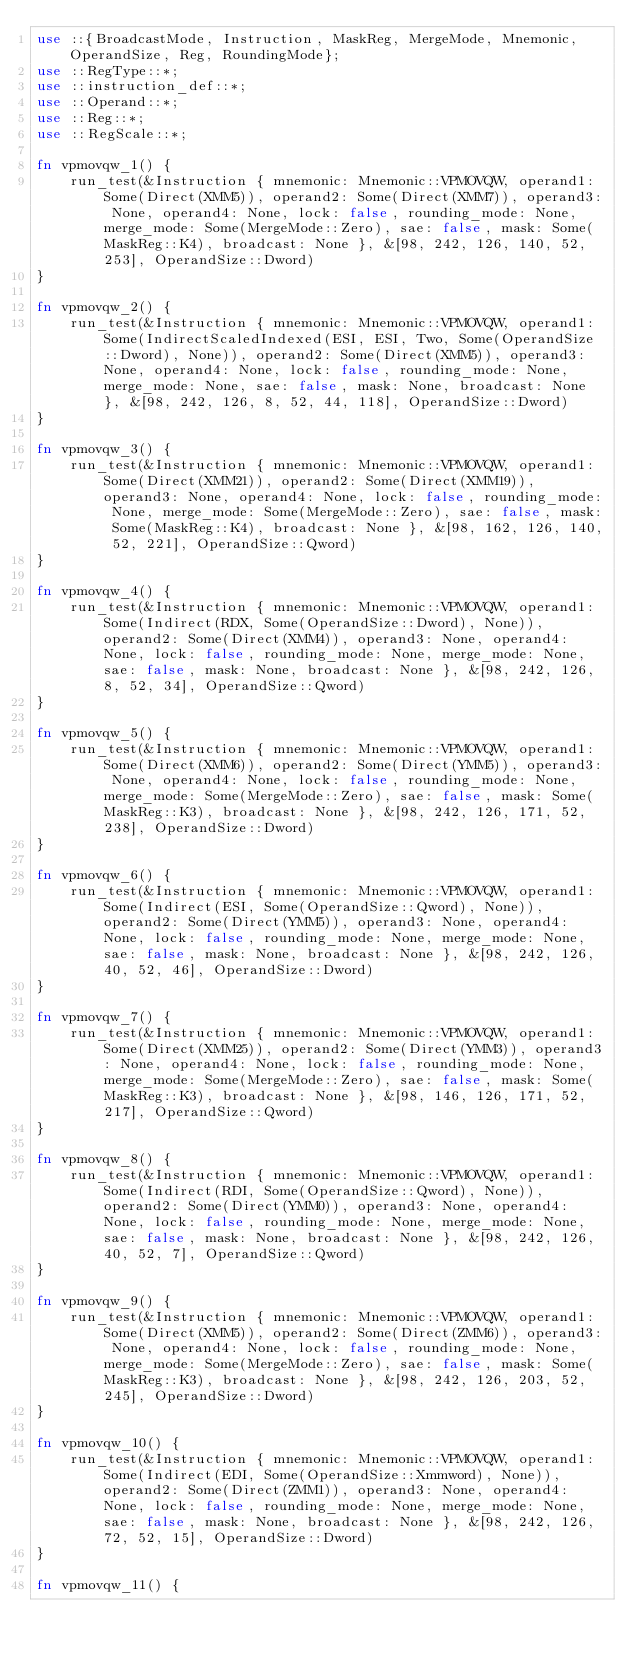<code> <loc_0><loc_0><loc_500><loc_500><_Rust_>use ::{BroadcastMode, Instruction, MaskReg, MergeMode, Mnemonic, OperandSize, Reg, RoundingMode};
use ::RegType::*;
use ::instruction_def::*;
use ::Operand::*;
use ::Reg::*;
use ::RegScale::*;

fn vpmovqw_1() {
    run_test(&Instruction { mnemonic: Mnemonic::VPMOVQW, operand1: Some(Direct(XMM5)), operand2: Some(Direct(XMM7)), operand3: None, operand4: None, lock: false, rounding_mode: None, merge_mode: Some(MergeMode::Zero), sae: false, mask: Some(MaskReg::K4), broadcast: None }, &[98, 242, 126, 140, 52, 253], OperandSize::Dword)
}

fn vpmovqw_2() {
    run_test(&Instruction { mnemonic: Mnemonic::VPMOVQW, operand1: Some(IndirectScaledIndexed(ESI, ESI, Two, Some(OperandSize::Dword), None)), operand2: Some(Direct(XMM5)), operand3: None, operand4: None, lock: false, rounding_mode: None, merge_mode: None, sae: false, mask: None, broadcast: None }, &[98, 242, 126, 8, 52, 44, 118], OperandSize::Dword)
}

fn vpmovqw_3() {
    run_test(&Instruction { mnemonic: Mnemonic::VPMOVQW, operand1: Some(Direct(XMM21)), operand2: Some(Direct(XMM19)), operand3: None, operand4: None, lock: false, rounding_mode: None, merge_mode: Some(MergeMode::Zero), sae: false, mask: Some(MaskReg::K4), broadcast: None }, &[98, 162, 126, 140, 52, 221], OperandSize::Qword)
}

fn vpmovqw_4() {
    run_test(&Instruction { mnemonic: Mnemonic::VPMOVQW, operand1: Some(Indirect(RDX, Some(OperandSize::Dword), None)), operand2: Some(Direct(XMM4)), operand3: None, operand4: None, lock: false, rounding_mode: None, merge_mode: None, sae: false, mask: None, broadcast: None }, &[98, 242, 126, 8, 52, 34], OperandSize::Qword)
}

fn vpmovqw_5() {
    run_test(&Instruction { mnemonic: Mnemonic::VPMOVQW, operand1: Some(Direct(XMM6)), operand2: Some(Direct(YMM5)), operand3: None, operand4: None, lock: false, rounding_mode: None, merge_mode: Some(MergeMode::Zero), sae: false, mask: Some(MaskReg::K3), broadcast: None }, &[98, 242, 126, 171, 52, 238], OperandSize::Dword)
}

fn vpmovqw_6() {
    run_test(&Instruction { mnemonic: Mnemonic::VPMOVQW, operand1: Some(Indirect(ESI, Some(OperandSize::Qword), None)), operand2: Some(Direct(YMM5)), operand3: None, operand4: None, lock: false, rounding_mode: None, merge_mode: None, sae: false, mask: None, broadcast: None }, &[98, 242, 126, 40, 52, 46], OperandSize::Dword)
}

fn vpmovqw_7() {
    run_test(&Instruction { mnemonic: Mnemonic::VPMOVQW, operand1: Some(Direct(XMM25)), operand2: Some(Direct(YMM3)), operand3: None, operand4: None, lock: false, rounding_mode: None, merge_mode: Some(MergeMode::Zero), sae: false, mask: Some(MaskReg::K3), broadcast: None }, &[98, 146, 126, 171, 52, 217], OperandSize::Qword)
}

fn vpmovqw_8() {
    run_test(&Instruction { mnemonic: Mnemonic::VPMOVQW, operand1: Some(Indirect(RDI, Some(OperandSize::Qword), None)), operand2: Some(Direct(YMM0)), operand3: None, operand4: None, lock: false, rounding_mode: None, merge_mode: None, sae: false, mask: None, broadcast: None }, &[98, 242, 126, 40, 52, 7], OperandSize::Qword)
}

fn vpmovqw_9() {
    run_test(&Instruction { mnemonic: Mnemonic::VPMOVQW, operand1: Some(Direct(XMM5)), operand2: Some(Direct(ZMM6)), operand3: None, operand4: None, lock: false, rounding_mode: None, merge_mode: Some(MergeMode::Zero), sae: false, mask: Some(MaskReg::K3), broadcast: None }, &[98, 242, 126, 203, 52, 245], OperandSize::Dword)
}

fn vpmovqw_10() {
    run_test(&Instruction { mnemonic: Mnemonic::VPMOVQW, operand1: Some(Indirect(EDI, Some(OperandSize::Xmmword), None)), operand2: Some(Direct(ZMM1)), operand3: None, operand4: None, lock: false, rounding_mode: None, merge_mode: None, sae: false, mask: None, broadcast: None }, &[98, 242, 126, 72, 52, 15], OperandSize::Dword)
}

fn vpmovqw_11() {</code> 